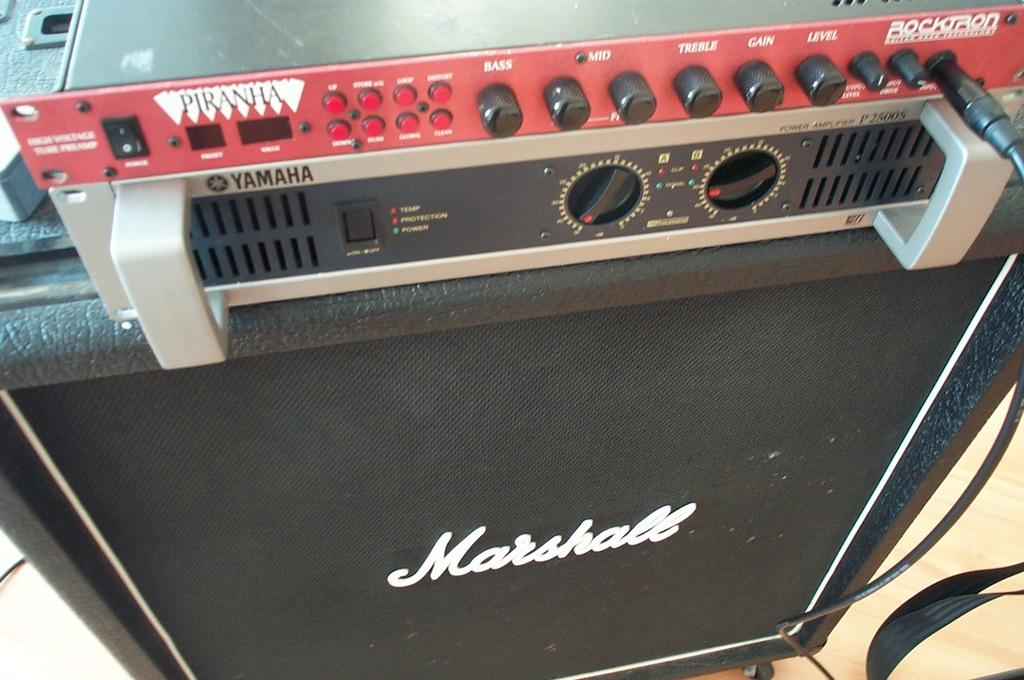<image>
Present a compact description of the photo's key features. A Marshall speaker has a yamaha sound board on top 